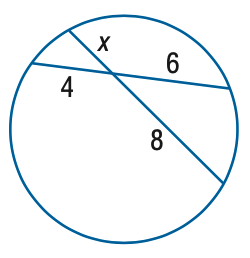Answer the mathemtical geometry problem and directly provide the correct option letter.
Question: Find x.
Choices: A: 3 B: 4 C: 5 D: 6 A 